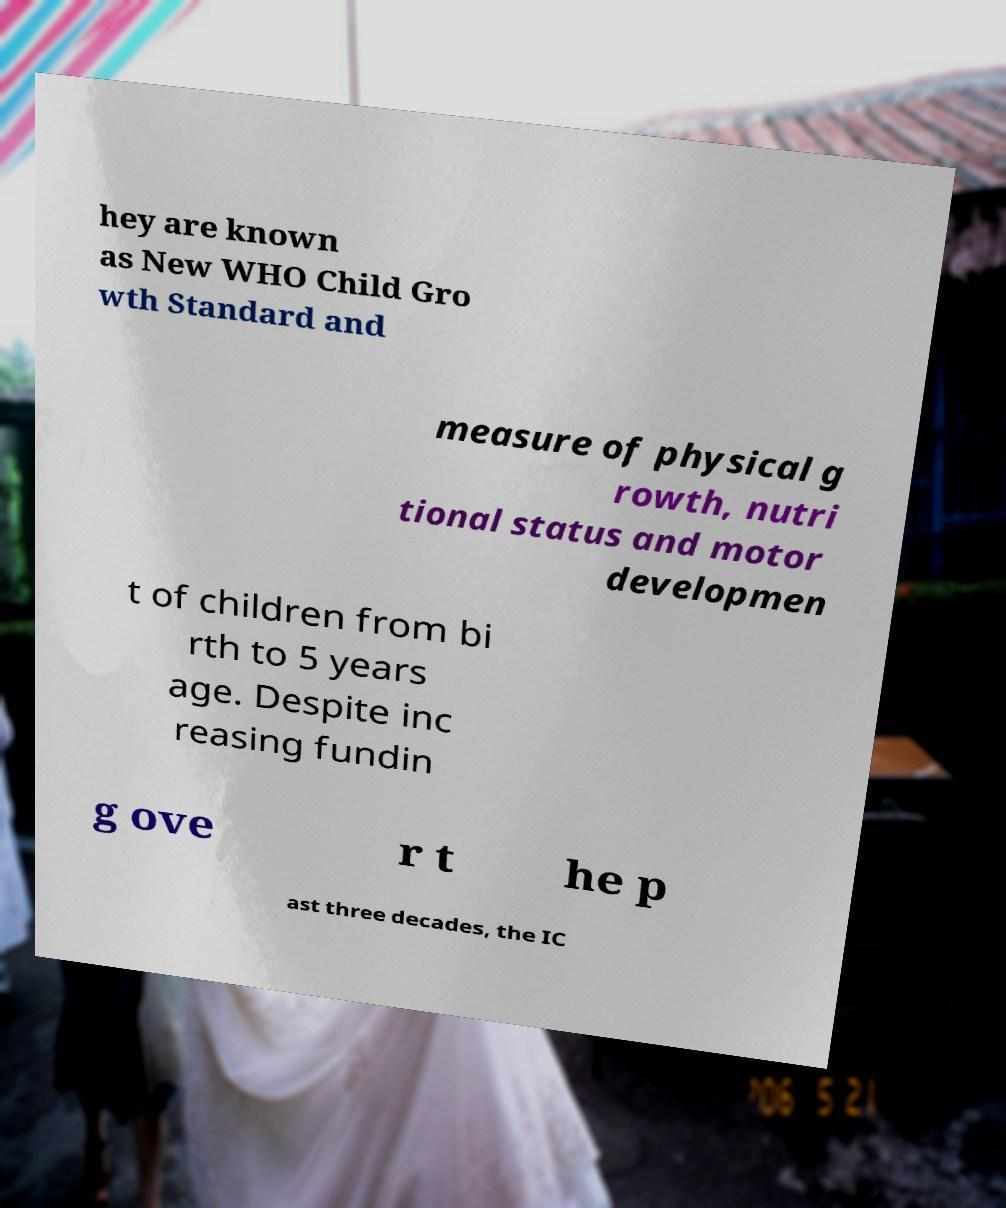Please identify and transcribe the text found in this image. hey are known as New WHO Child Gro wth Standard and measure of physical g rowth, nutri tional status and motor developmen t of children from bi rth to 5 years age. Despite inc reasing fundin g ove r t he p ast three decades, the IC 